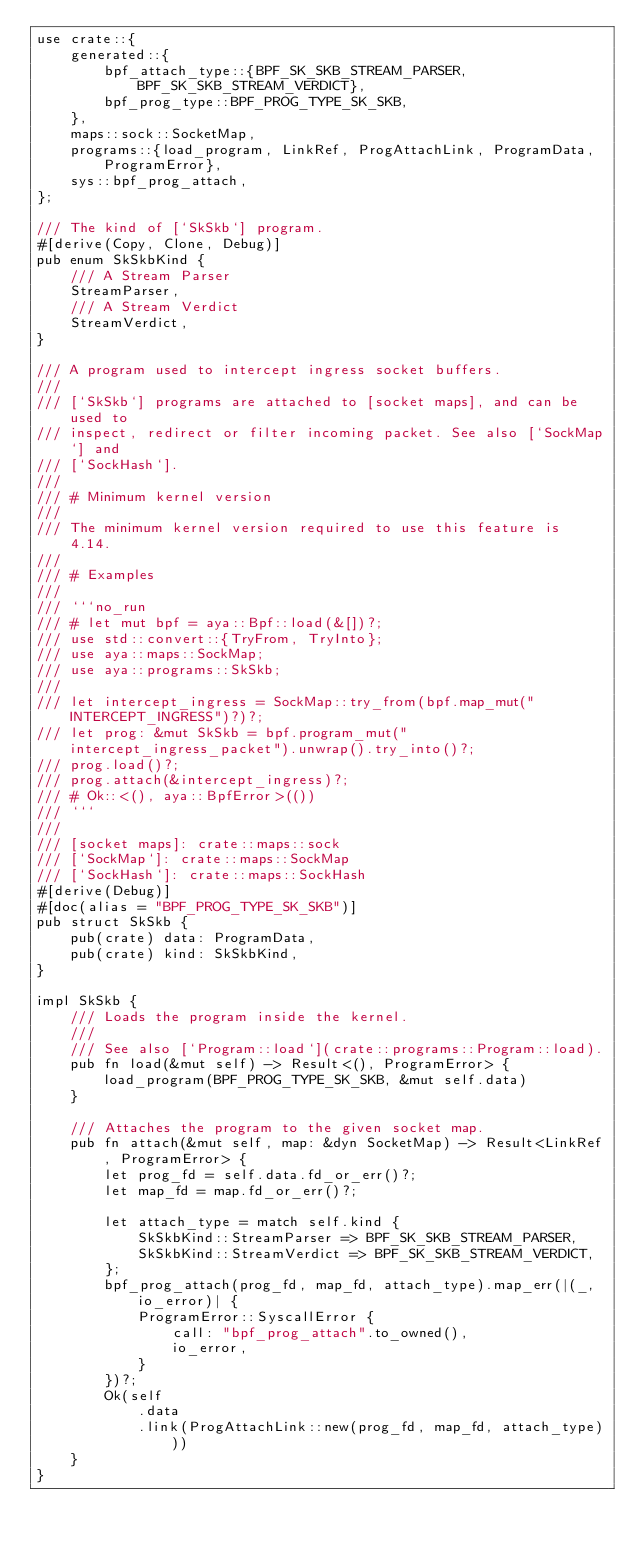Convert code to text. <code><loc_0><loc_0><loc_500><loc_500><_Rust_>use crate::{
    generated::{
        bpf_attach_type::{BPF_SK_SKB_STREAM_PARSER, BPF_SK_SKB_STREAM_VERDICT},
        bpf_prog_type::BPF_PROG_TYPE_SK_SKB,
    },
    maps::sock::SocketMap,
    programs::{load_program, LinkRef, ProgAttachLink, ProgramData, ProgramError},
    sys::bpf_prog_attach,
};

/// The kind of [`SkSkb`] program.
#[derive(Copy, Clone, Debug)]
pub enum SkSkbKind {
    /// A Stream Parser
    StreamParser,
    /// A Stream Verdict
    StreamVerdict,
}

/// A program used to intercept ingress socket buffers.
///
/// [`SkSkb`] programs are attached to [socket maps], and can be used to
/// inspect, redirect or filter incoming packet. See also [`SockMap`] and
/// [`SockHash`].
///
/// # Minimum kernel version
///
/// The minimum kernel version required to use this feature is 4.14.
///
/// # Examples
///
/// ```no_run
/// # let mut bpf = aya::Bpf::load(&[])?;
/// use std::convert::{TryFrom, TryInto};
/// use aya::maps::SockMap;
/// use aya::programs::SkSkb;
///
/// let intercept_ingress = SockMap::try_from(bpf.map_mut("INTERCEPT_INGRESS")?)?;
/// let prog: &mut SkSkb = bpf.program_mut("intercept_ingress_packet").unwrap().try_into()?;
/// prog.load()?;
/// prog.attach(&intercept_ingress)?;
/// # Ok::<(), aya::BpfError>(())
/// ```
///
/// [socket maps]: crate::maps::sock
/// [`SockMap`]: crate::maps::SockMap
/// [`SockHash`]: crate::maps::SockHash
#[derive(Debug)]
#[doc(alias = "BPF_PROG_TYPE_SK_SKB")]
pub struct SkSkb {
    pub(crate) data: ProgramData,
    pub(crate) kind: SkSkbKind,
}

impl SkSkb {
    /// Loads the program inside the kernel.
    ///
    /// See also [`Program::load`](crate::programs::Program::load).
    pub fn load(&mut self) -> Result<(), ProgramError> {
        load_program(BPF_PROG_TYPE_SK_SKB, &mut self.data)
    }

    /// Attaches the program to the given socket map.
    pub fn attach(&mut self, map: &dyn SocketMap) -> Result<LinkRef, ProgramError> {
        let prog_fd = self.data.fd_or_err()?;
        let map_fd = map.fd_or_err()?;

        let attach_type = match self.kind {
            SkSkbKind::StreamParser => BPF_SK_SKB_STREAM_PARSER,
            SkSkbKind::StreamVerdict => BPF_SK_SKB_STREAM_VERDICT,
        };
        bpf_prog_attach(prog_fd, map_fd, attach_type).map_err(|(_, io_error)| {
            ProgramError::SyscallError {
                call: "bpf_prog_attach".to_owned(),
                io_error,
            }
        })?;
        Ok(self
            .data
            .link(ProgAttachLink::new(prog_fd, map_fd, attach_type)))
    }
}
</code> 